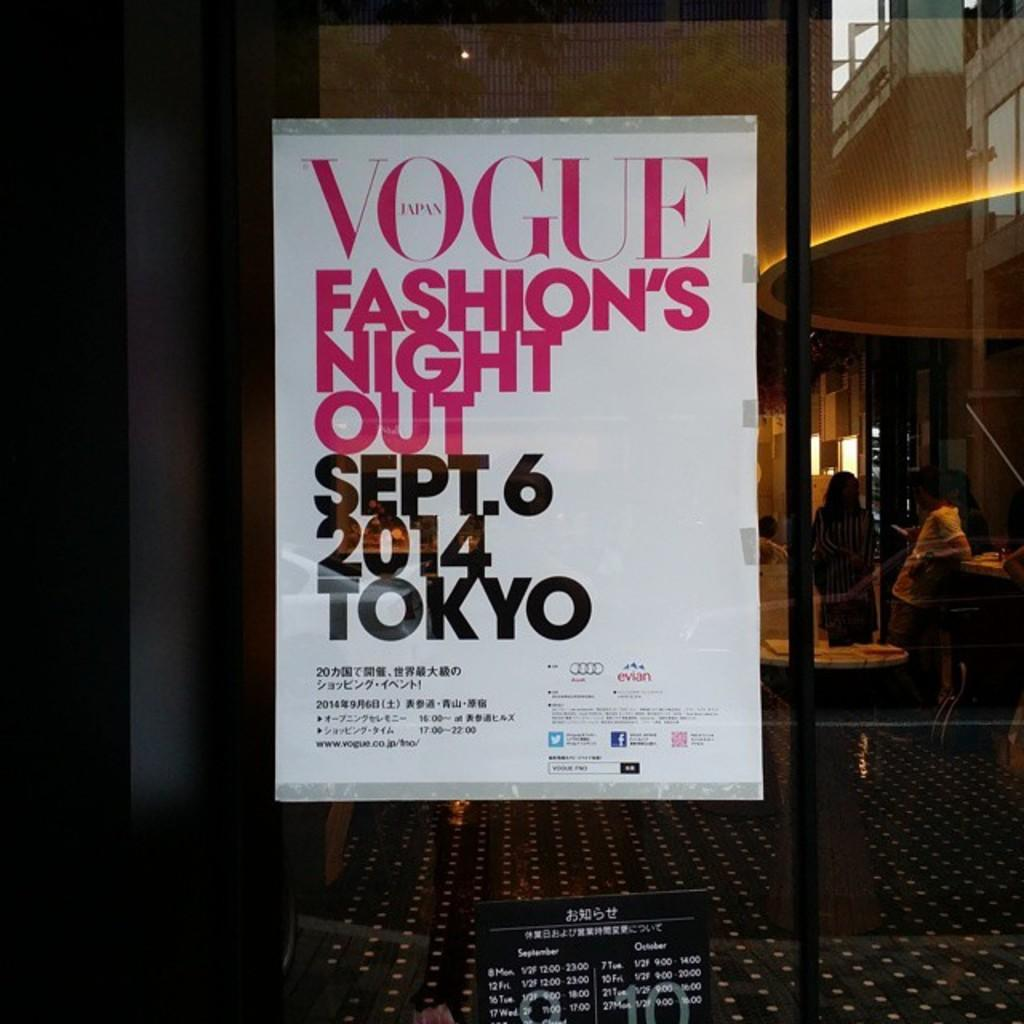<image>
Describe the image concisely. A poster of Vogue's Fashion Night Out in Tokyo hanging in a store window. 